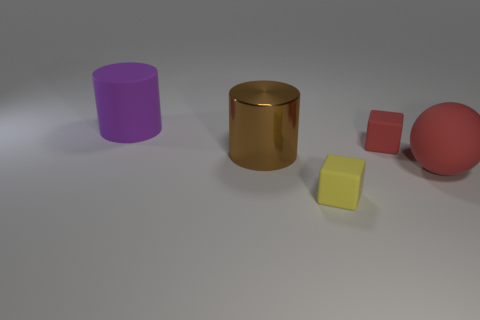Are there any other things that have the same material as the brown thing?
Ensure brevity in your answer.  No. How many objects are either big cylinders in front of the large purple rubber object or big spheres?
Provide a succinct answer. 2. Are there any objects of the same color as the big sphere?
Offer a terse response. Yes. There is a brown thing; does it have the same shape as the big matte thing that is on the left side of the matte ball?
Offer a very short reply. Yes. What number of objects are both behind the brown metal cylinder and left of the tiny yellow cube?
Give a very brief answer. 1. What material is the other thing that is the same shape as the small yellow thing?
Your response must be concise. Rubber. What is the size of the thing in front of the large rubber object in front of the big purple object?
Offer a very short reply. Small. Are any large blocks visible?
Your response must be concise. No. The thing that is both behind the large red rubber sphere and to the right of the tiny yellow rubber object is made of what material?
Give a very brief answer. Rubber. Is the number of small objects on the left side of the red rubber sphere greater than the number of big objects behind the large brown thing?
Offer a terse response. Yes. 